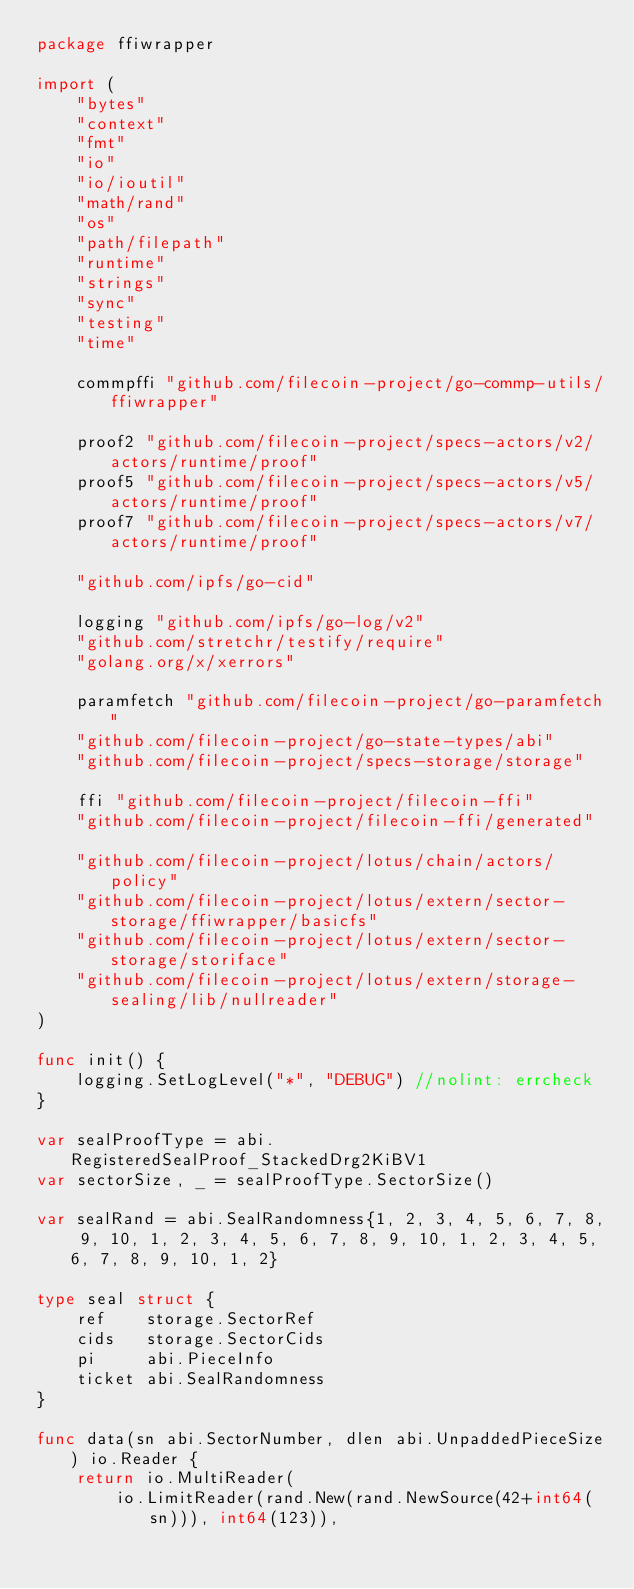Convert code to text. <code><loc_0><loc_0><loc_500><loc_500><_Go_>package ffiwrapper

import (
	"bytes"
	"context"
	"fmt"
	"io"
	"io/ioutil"
	"math/rand"
	"os"
	"path/filepath"
	"runtime"
	"strings"
	"sync"
	"testing"
	"time"

	commpffi "github.com/filecoin-project/go-commp-utils/ffiwrapper"

	proof2 "github.com/filecoin-project/specs-actors/v2/actors/runtime/proof"
	proof5 "github.com/filecoin-project/specs-actors/v5/actors/runtime/proof"
	proof7 "github.com/filecoin-project/specs-actors/v7/actors/runtime/proof"

	"github.com/ipfs/go-cid"

	logging "github.com/ipfs/go-log/v2"
	"github.com/stretchr/testify/require"
	"golang.org/x/xerrors"

	paramfetch "github.com/filecoin-project/go-paramfetch"
	"github.com/filecoin-project/go-state-types/abi"
	"github.com/filecoin-project/specs-storage/storage"

	ffi "github.com/filecoin-project/filecoin-ffi"
	"github.com/filecoin-project/filecoin-ffi/generated"

	"github.com/filecoin-project/lotus/chain/actors/policy"
	"github.com/filecoin-project/lotus/extern/sector-storage/ffiwrapper/basicfs"
	"github.com/filecoin-project/lotus/extern/sector-storage/storiface"
	"github.com/filecoin-project/lotus/extern/storage-sealing/lib/nullreader"
)

func init() {
	logging.SetLogLevel("*", "DEBUG") //nolint: errcheck
}

var sealProofType = abi.RegisteredSealProof_StackedDrg2KiBV1
var sectorSize, _ = sealProofType.SectorSize()

var sealRand = abi.SealRandomness{1, 2, 3, 4, 5, 6, 7, 8, 9, 10, 1, 2, 3, 4, 5, 6, 7, 8, 9, 10, 1, 2, 3, 4, 5, 6, 7, 8, 9, 10, 1, 2}

type seal struct {
	ref    storage.SectorRef
	cids   storage.SectorCids
	pi     abi.PieceInfo
	ticket abi.SealRandomness
}

func data(sn abi.SectorNumber, dlen abi.UnpaddedPieceSize) io.Reader {
	return io.MultiReader(
		io.LimitReader(rand.New(rand.NewSource(42+int64(sn))), int64(123)),</code> 